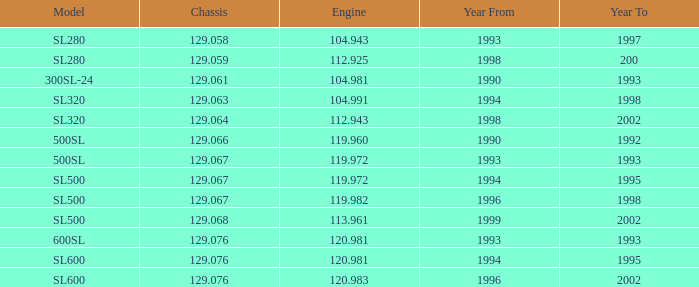Which engine corresponds to an sl500 model with a manufacturing year later than 1999? None. 